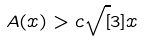Convert formula to latex. <formula><loc_0><loc_0><loc_500><loc_500>A ( x ) > c \sqrt { [ } 3 ] { x }</formula> 